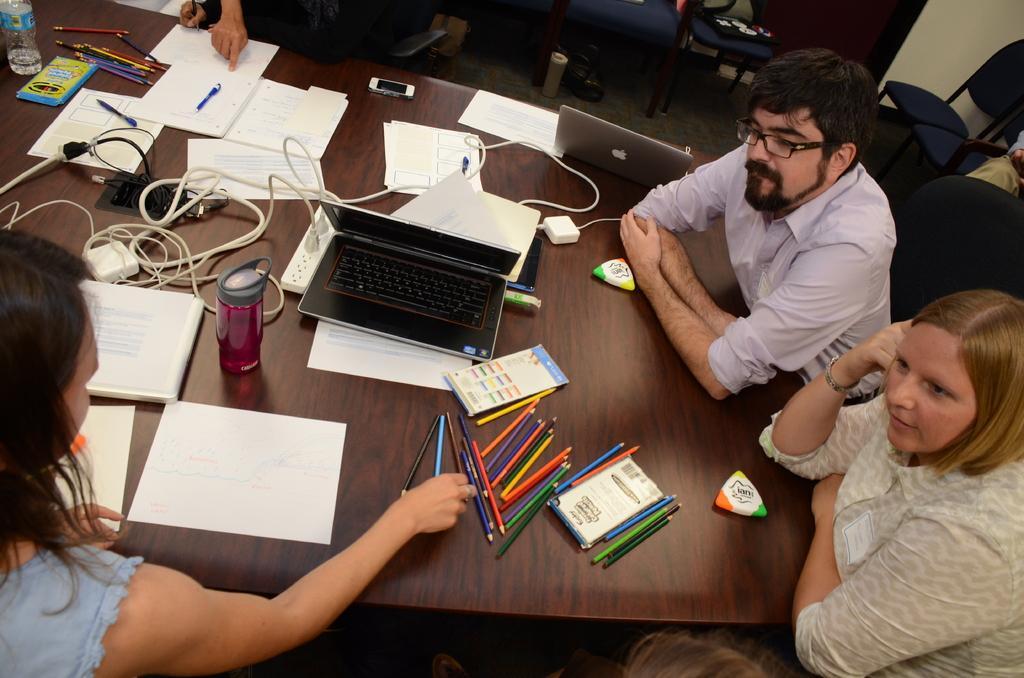How would you summarize this image in a sentence or two? In this picture there is table on which some pens, papers ,Water bottles, wires, chargers, mobiles, laptops were placed. Around the table, there are some people sitting here. In the background there is a wall here. 